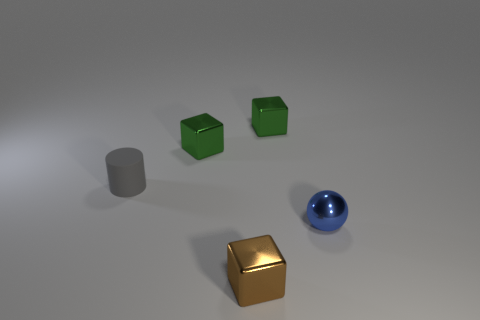Does the tiny cube in front of the gray cylinder have the same material as the blue sphere?
Provide a succinct answer. Yes. Are there more blue objects behind the ball than gray matte objects that are left of the gray matte cylinder?
Your answer should be very brief. No. What is the material of the cylinder that is the same size as the brown thing?
Offer a very short reply. Rubber. What number of other things are made of the same material as the tiny cylinder?
Your answer should be compact. 0. Does the green object left of the tiny brown shiny object have the same shape as the small blue thing behind the tiny brown cube?
Keep it short and to the point. No. What number of other things are there of the same color as the metal ball?
Provide a short and direct response. 0. Does the cube that is in front of the tiny gray cylinder have the same material as the small green cube on the right side of the small brown object?
Provide a short and direct response. Yes. Are there the same number of brown things on the right side of the small blue thing and small gray rubber objects in front of the gray cylinder?
Your response must be concise. Yes. There is a tiny green thing that is to the left of the small brown shiny thing; what is it made of?
Give a very brief answer. Metal. Is there any other thing that is the same size as the rubber object?
Provide a short and direct response. Yes. 